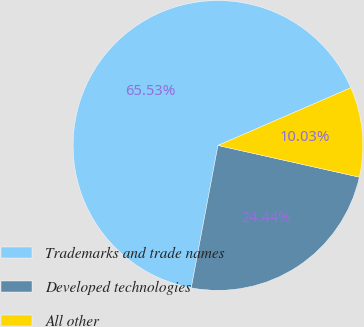<chart> <loc_0><loc_0><loc_500><loc_500><pie_chart><fcel>Trademarks and trade names<fcel>Developed technologies<fcel>All other<nl><fcel>65.53%<fcel>24.44%<fcel>10.03%<nl></chart> 